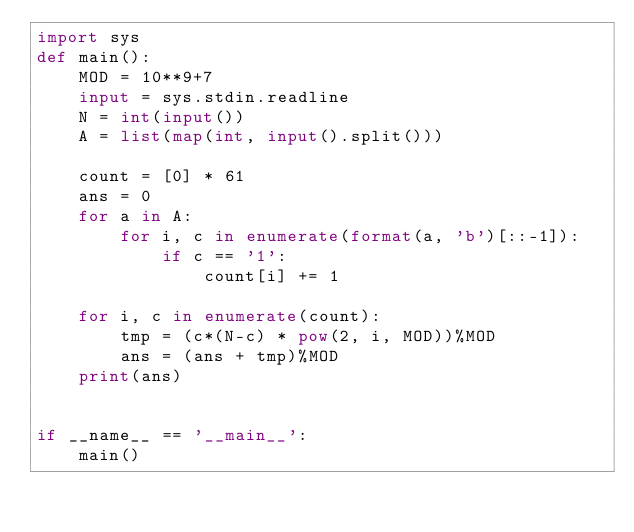<code> <loc_0><loc_0><loc_500><loc_500><_Python_>import sys
def main():
    MOD = 10**9+7
    input = sys.stdin.readline
    N = int(input())
    A = list(map(int, input().split()))

    count = [0] * 61
    ans = 0
    for a in A:
        for i, c in enumerate(format(a, 'b')[::-1]):
            if c == '1':
                count[i] += 1

    for i, c in enumerate(count):
        tmp = (c*(N-c) * pow(2, i, MOD))%MOD
        ans = (ans + tmp)%MOD
    print(ans)


if __name__ == '__main__':
    main()
</code> 